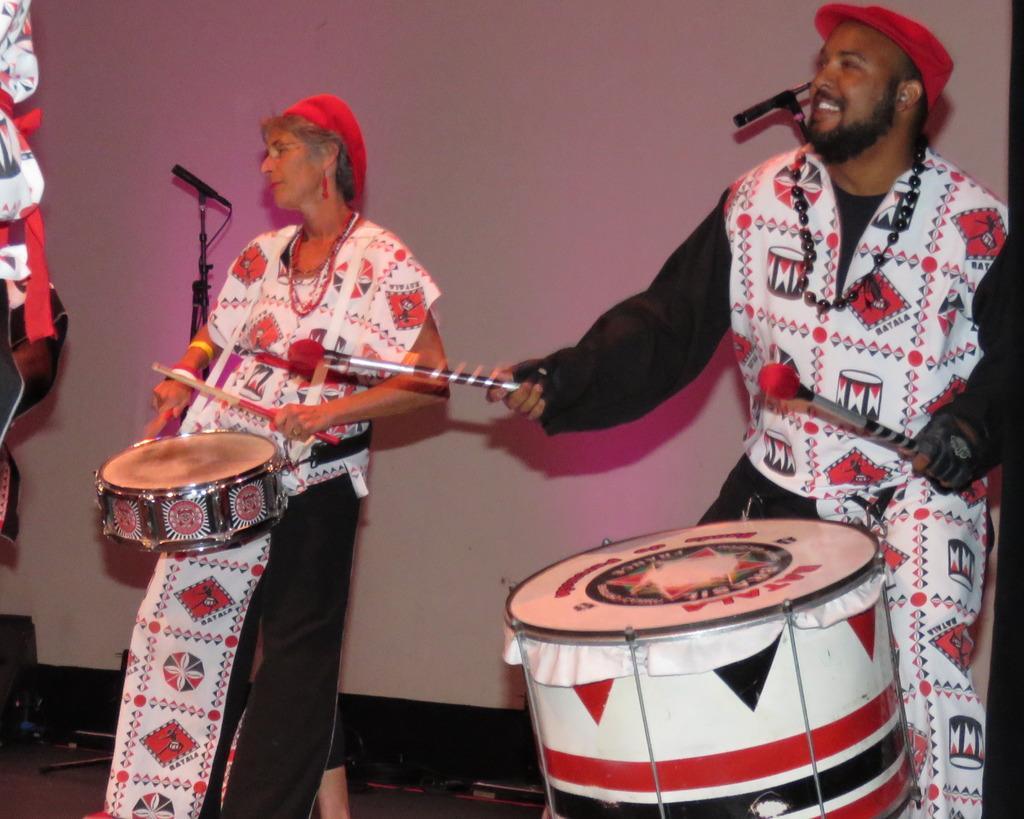How would you summarize this image in a sentence or two? In the center of the image we can see two people standing and beating drums. In the background there is a stand and a wall. 